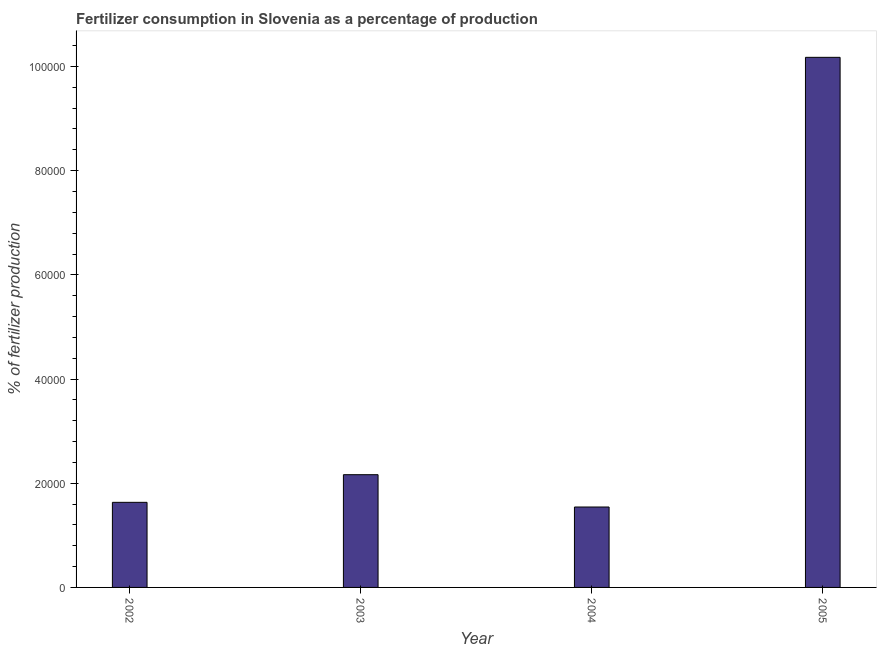Does the graph contain any zero values?
Offer a very short reply. No. Does the graph contain grids?
Give a very brief answer. No. What is the title of the graph?
Offer a terse response. Fertilizer consumption in Slovenia as a percentage of production. What is the label or title of the Y-axis?
Keep it short and to the point. % of fertilizer production. What is the amount of fertilizer consumption in 2002?
Ensure brevity in your answer.  1.63e+04. Across all years, what is the maximum amount of fertilizer consumption?
Your answer should be compact. 1.02e+05. Across all years, what is the minimum amount of fertilizer consumption?
Keep it short and to the point. 1.54e+04. What is the sum of the amount of fertilizer consumption?
Offer a terse response. 1.55e+05. What is the difference between the amount of fertilizer consumption in 2003 and 2005?
Your answer should be very brief. -8.01e+04. What is the average amount of fertilizer consumption per year?
Provide a succinct answer. 3.88e+04. What is the median amount of fertilizer consumption?
Your answer should be very brief. 1.90e+04. Do a majority of the years between 2002 and 2004 (inclusive) have amount of fertilizer consumption greater than 96000 %?
Make the answer very short. No. What is the ratio of the amount of fertilizer consumption in 2002 to that in 2004?
Make the answer very short. 1.06. Is the difference between the amount of fertilizer consumption in 2003 and 2005 greater than the difference between any two years?
Your answer should be compact. No. What is the difference between the highest and the second highest amount of fertilizer consumption?
Your response must be concise. 8.01e+04. Is the sum of the amount of fertilizer consumption in 2004 and 2005 greater than the maximum amount of fertilizer consumption across all years?
Make the answer very short. Yes. What is the difference between the highest and the lowest amount of fertilizer consumption?
Ensure brevity in your answer.  8.63e+04. How many bars are there?
Ensure brevity in your answer.  4. How many years are there in the graph?
Offer a terse response. 4. What is the difference between two consecutive major ticks on the Y-axis?
Offer a terse response. 2.00e+04. Are the values on the major ticks of Y-axis written in scientific E-notation?
Your answer should be compact. No. What is the % of fertilizer production in 2002?
Provide a succinct answer. 1.63e+04. What is the % of fertilizer production of 2003?
Offer a very short reply. 2.16e+04. What is the % of fertilizer production of 2004?
Offer a terse response. 1.54e+04. What is the % of fertilizer production in 2005?
Give a very brief answer. 1.02e+05. What is the difference between the % of fertilizer production in 2002 and 2003?
Give a very brief answer. -5307.13. What is the difference between the % of fertilizer production in 2002 and 2004?
Offer a terse response. 898.04. What is the difference between the % of fertilizer production in 2002 and 2005?
Give a very brief answer. -8.54e+04. What is the difference between the % of fertilizer production in 2003 and 2004?
Offer a very short reply. 6205.17. What is the difference between the % of fertilizer production in 2003 and 2005?
Keep it short and to the point. -8.01e+04. What is the difference between the % of fertilizer production in 2004 and 2005?
Keep it short and to the point. -8.63e+04. What is the ratio of the % of fertilizer production in 2002 to that in 2003?
Offer a very short reply. 0.76. What is the ratio of the % of fertilizer production in 2002 to that in 2004?
Your response must be concise. 1.06. What is the ratio of the % of fertilizer production in 2002 to that in 2005?
Offer a very short reply. 0.16. What is the ratio of the % of fertilizer production in 2003 to that in 2004?
Keep it short and to the point. 1.4. What is the ratio of the % of fertilizer production in 2003 to that in 2005?
Offer a terse response. 0.21. What is the ratio of the % of fertilizer production in 2004 to that in 2005?
Keep it short and to the point. 0.15. 